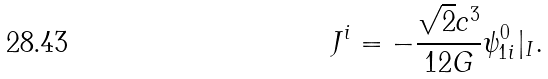Convert formula to latex. <formula><loc_0><loc_0><loc_500><loc_500>J ^ { i } = - \frac { \sqrt { 2 } c ^ { 3 } } { 1 2 G } \psi _ { 1 i } ^ { 0 } | _ { I } .</formula> 